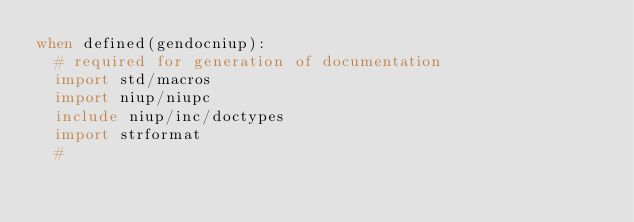Convert code to text. <code><loc_0><loc_0><loc_500><loc_500><_Nim_>when defined(gendocniup):
  # required for generation of documentation
  import std/macros
  import niup/niupc
  include niup/inc/doctypes
  import strformat
  #
</code> 